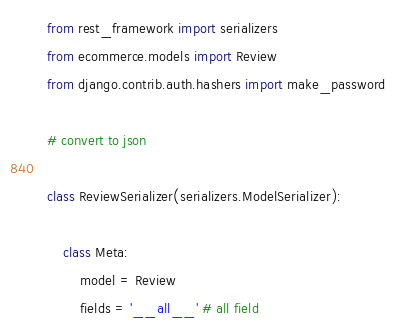<code> <loc_0><loc_0><loc_500><loc_500><_Python_>from rest_framework import serializers
from ecommerce.models import Review
from django.contrib.auth.hashers import make_password

# convert to json

class ReviewSerializer(serializers.ModelSerializer):

    class Meta:
        model = Review
        fields = '__all__' # all field</code> 